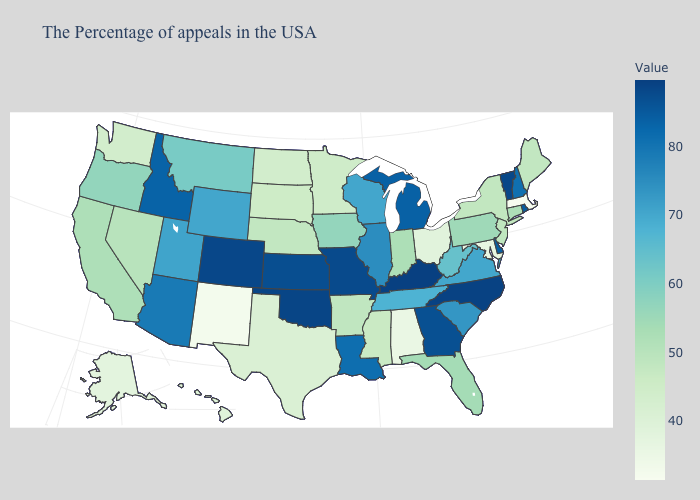Does Massachusetts have the lowest value in the Northeast?
Concise answer only. Yes. Which states have the lowest value in the USA?
Quick response, please. Massachusetts. Which states have the lowest value in the West?
Concise answer only. New Mexico. Does New Mexico have the lowest value in the West?
Write a very short answer. Yes. Is the legend a continuous bar?
Give a very brief answer. Yes. 